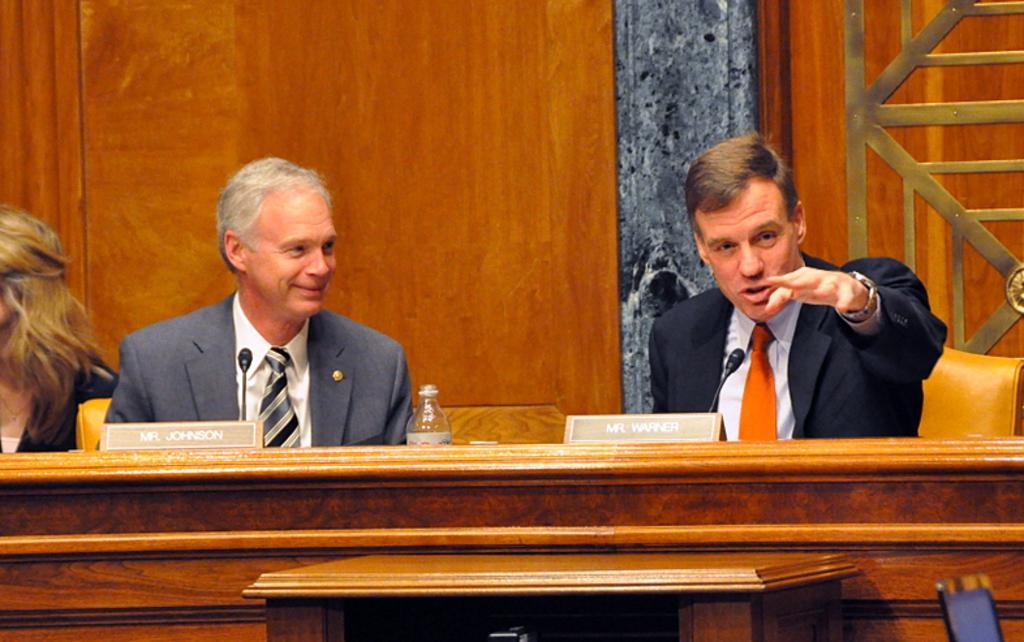In one or two sentences, can you explain what this image depicts? Here we can see two men and on the left a woman sitting on the chair at the table. On the table we can see a water bottle. In the background there is a wall. On the right at the bottom corner we can see an electronic device. 